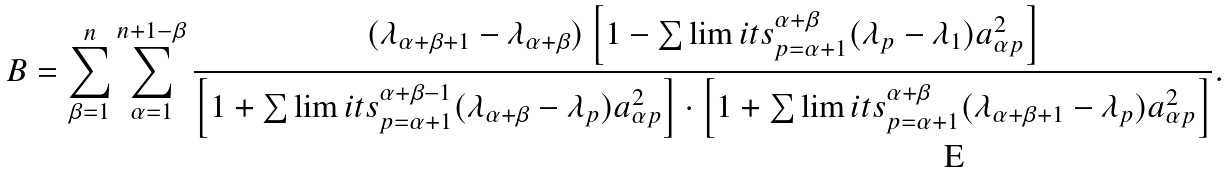Convert formula to latex. <formula><loc_0><loc_0><loc_500><loc_500>B = \sum _ { \beta = 1 } ^ { n } \sum _ { \alpha = 1 } ^ { n + 1 - \beta } \frac { ( \lambda _ { \alpha + \beta + 1 } - \lambda _ { \alpha + \beta } ) \left [ 1 - \sum \lim i t s _ { p = \alpha + 1 } ^ { \alpha + \beta } ( \lambda _ { p } - \lambda _ { 1 } ) a _ { \alpha p } ^ { 2 } \right ] } { \left [ 1 + \sum \lim i t s _ { p = \alpha + 1 } ^ { \alpha + \beta - 1 } ( \lambda _ { \alpha + \beta } - \lambda _ { p } ) a _ { \alpha p } ^ { 2 } \right ] \cdot \left [ 1 + \sum \lim i t s _ { p = \alpha + 1 } ^ { \alpha + \beta } ( \lambda _ { \alpha + \beta + 1 } - \lambda _ { p } ) a _ { \alpha p } ^ { 2 } \right ] } .</formula> 